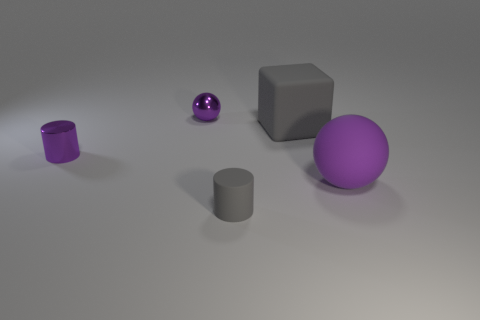Are there any tiny things that have the same color as the big cube?
Your answer should be very brief. Yes. What size is the matte block that is the same color as the matte cylinder?
Provide a short and direct response. Large. There is a cylinder that is to the left of the tiny gray thing; is its size the same as the purple sphere that is left of the big block?
Your answer should be compact. Yes. What is the size of the gray thing that is behind the small purple cylinder?
Offer a very short reply. Large. What is the material of the cylinder that is the same color as the big block?
Your answer should be compact. Rubber. What is the color of the rubber thing that is the same size as the rubber block?
Keep it short and to the point. Purple. Do the gray rubber cube and the purple cylinder have the same size?
Provide a succinct answer. No. What is the size of the purple thing that is in front of the big gray thing and left of the gray rubber cylinder?
Ensure brevity in your answer.  Small. What number of metal things are either gray objects or small purple things?
Make the answer very short. 2. Is the number of matte objects to the right of the rubber cube greater than the number of large gray things?
Your response must be concise. No. 